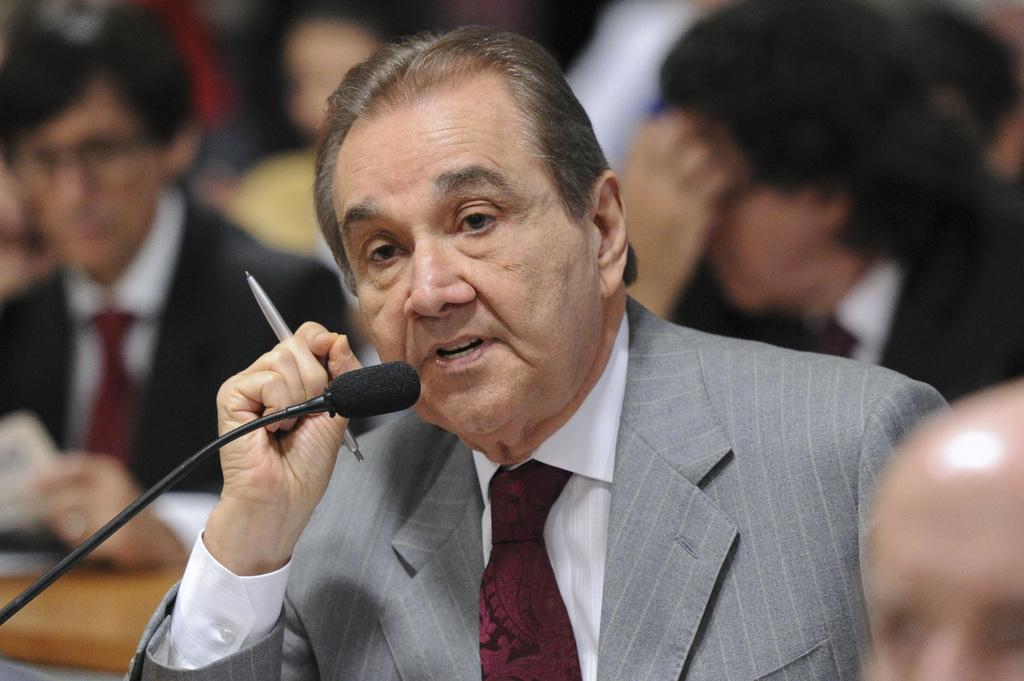What is the main subject of the image? The main subject of the image is a man. What is the man wearing? The man is wearing a blazer. What object is the man holding? The man is holding a pen. What might the man be doing in the image? The man appears to be explaining something, as he is holding a pen and there is a microphone in front of him. Can you describe the background of the image? There are blurred people behind the man, suggesting that he is in a public setting or giving a presentation. What type of brick is being used to build the office in the image? There is no office or brick present in the image; it features a man in a blazer holding a pen and standing in front of a microphone. Can you tell me the age of the man's grandfather in the image? There is no mention of a grandfather or any family members in the image; it only features a man in a blazer holding a pen and standing in front of a microphone. 